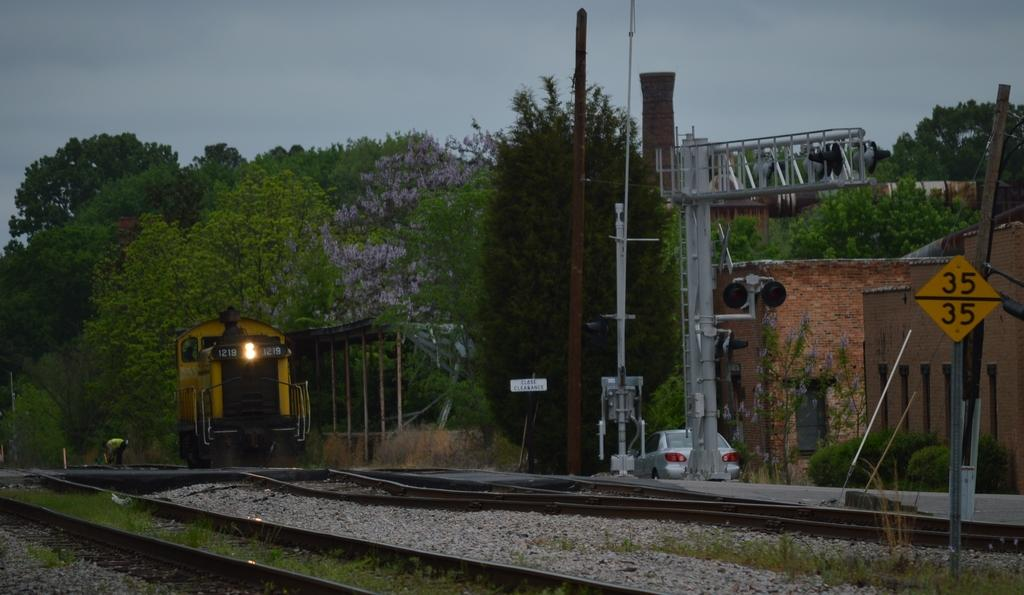What is the main subject of the image? The main subject of the image is a train engine. What can be seen in the background of the image? There are trees in the image. What is the train engine positioned on? There is a railway track in the image. What structures are present alongside the railway track? There are poles in the image. What information might be conveyed by the sign board in the image? The sign board in the image might convey information about the railway or the surrounding area. What type of news can be seen being delivered by the train in the image? There is no news being delivered by the train in the image; it is a static image of a train engine. What type of lumber is being transported by the train in the image? There is no lumber visible in the image; it only shows a train engine and other elements. 